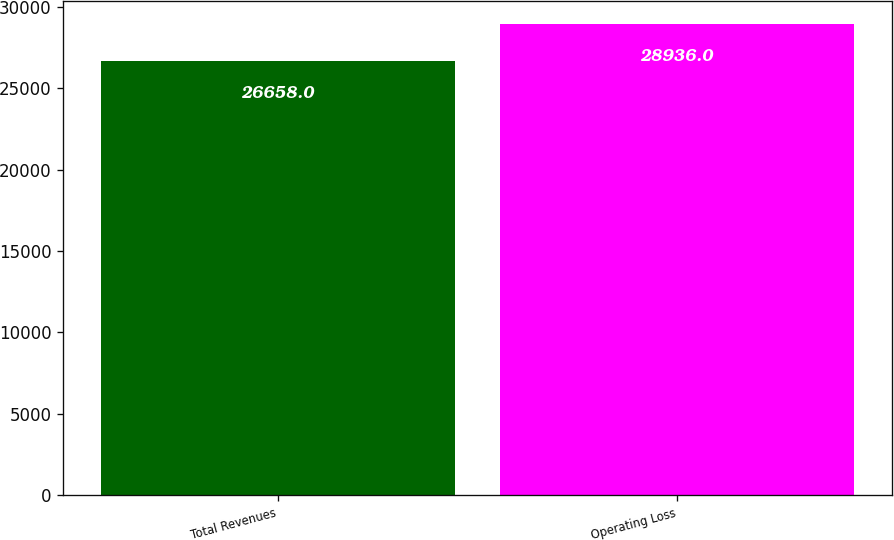<chart> <loc_0><loc_0><loc_500><loc_500><bar_chart><fcel>Total Revenues<fcel>Operating Loss<nl><fcel>26658<fcel>28936<nl></chart> 